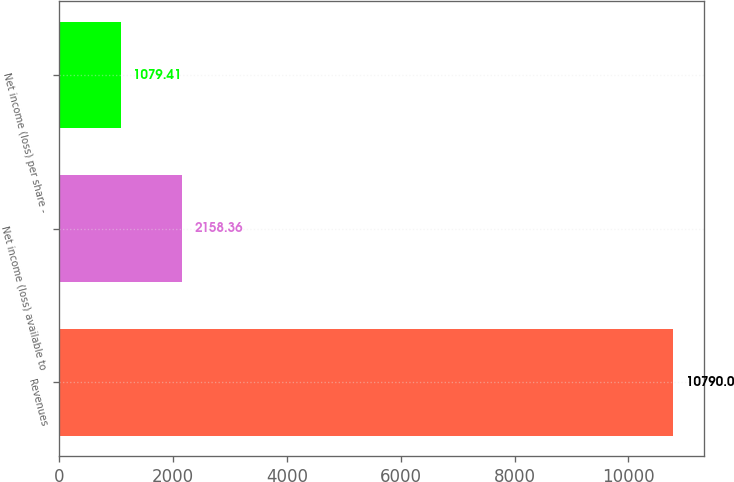Convert chart to OTSL. <chart><loc_0><loc_0><loc_500><loc_500><bar_chart><fcel>Revenues<fcel>Net income (loss) available to<fcel>Net income (loss) per share -<nl><fcel>10790<fcel>2158.36<fcel>1079.41<nl></chart> 